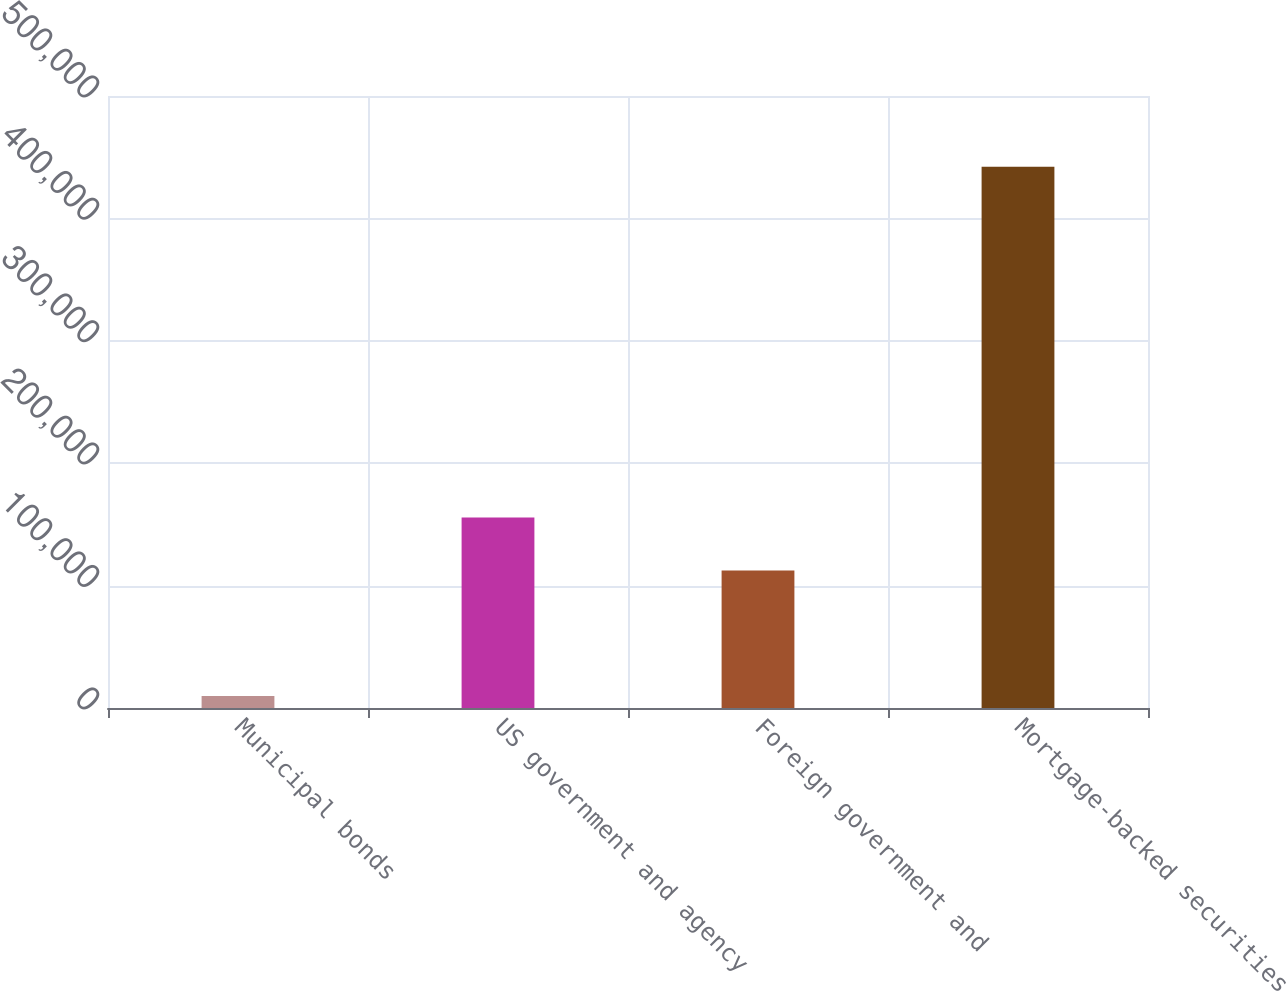Convert chart. <chart><loc_0><loc_0><loc_500><loc_500><bar_chart><fcel>Municipal bonds<fcel>US government and agency<fcel>Foreign government and<fcel>Mortgage-backed securities<nl><fcel>9703<fcel>155680<fcel>112430<fcel>442199<nl></chart> 